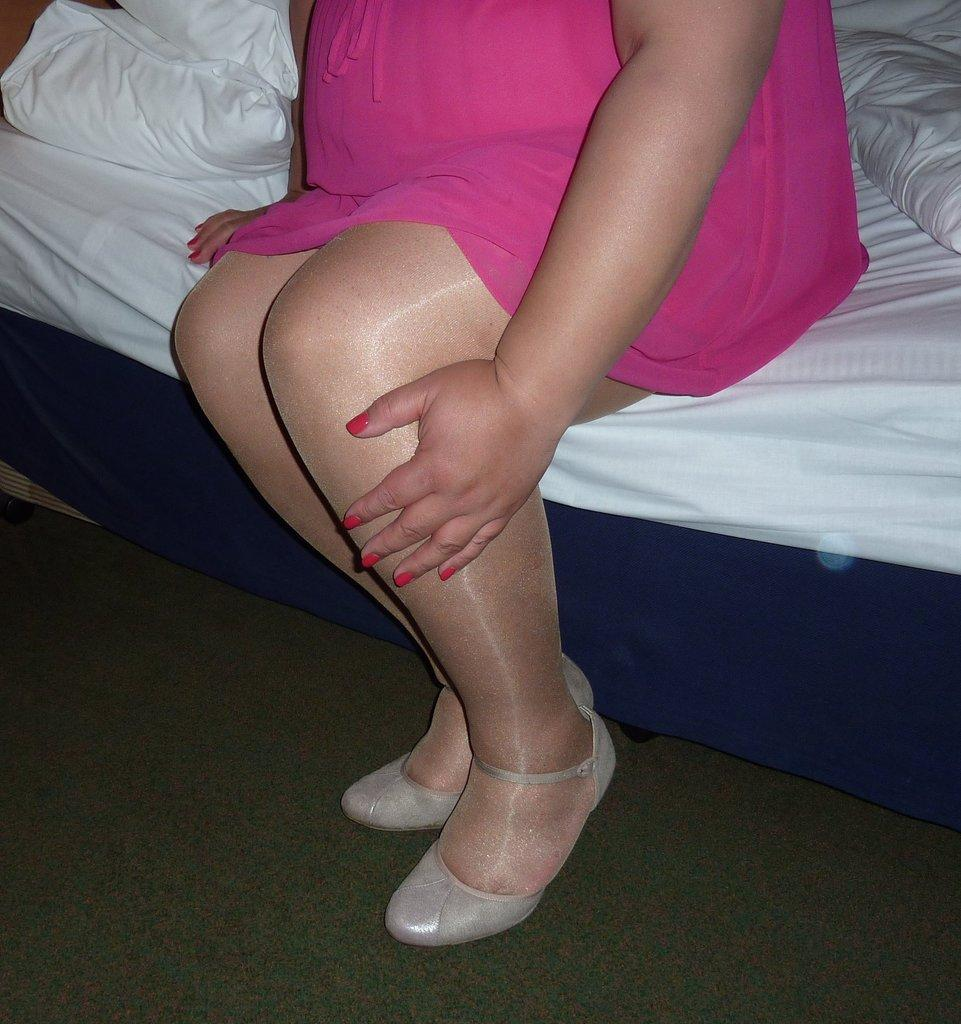Who is present in the image? There is a woman in the picture. What is the woman wearing on her feet? The woman is wearing footwear. Where is the woman sitting in the image? The woman is sitting on the bed. What else can be seen on the bed? There are pillows on the bed. What color is the toothbrush the woman is using in the image? There is no toothbrush present in the image, so it is not possible to determine its color. 